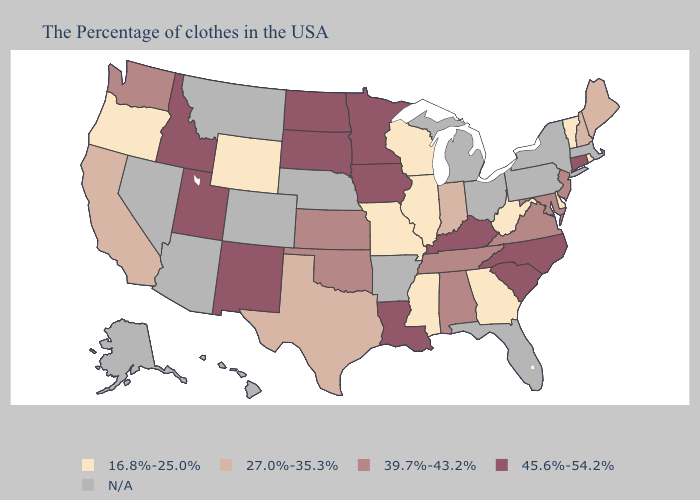Does Maine have the highest value in the Northeast?
Concise answer only. No. Name the states that have a value in the range N/A?
Keep it brief. Massachusetts, New York, Pennsylvania, Ohio, Florida, Michigan, Arkansas, Nebraska, Colorado, Montana, Arizona, Nevada, Alaska, Hawaii. Which states have the highest value in the USA?
Keep it brief. Connecticut, North Carolina, South Carolina, Kentucky, Louisiana, Minnesota, Iowa, South Dakota, North Dakota, New Mexico, Utah, Idaho. Name the states that have a value in the range 45.6%-54.2%?
Answer briefly. Connecticut, North Carolina, South Carolina, Kentucky, Louisiana, Minnesota, Iowa, South Dakota, North Dakota, New Mexico, Utah, Idaho. Which states have the lowest value in the South?
Quick response, please. Delaware, West Virginia, Georgia, Mississippi. How many symbols are there in the legend?
Give a very brief answer. 5. What is the lowest value in states that border Nevada?
Short answer required. 16.8%-25.0%. What is the highest value in states that border Kentucky?
Keep it brief. 39.7%-43.2%. What is the value of Maine?
Give a very brief answer. 27.0%-35.3%. What is the lowest value in the USA?
Keep it brief. 16.8%-25.0%. What is the value of Wyoming?
Write a very short answer. 16.8%-25.0%. Name the states that have a value in the range N/A?
Keep it brief. Massachusetts, New York, Pennsylvania, Ohio, Florida, Michigan, Arkansas, Nebraska, Colorado, Montana, Arizona, Nevada, Alaska, Hawaii. 